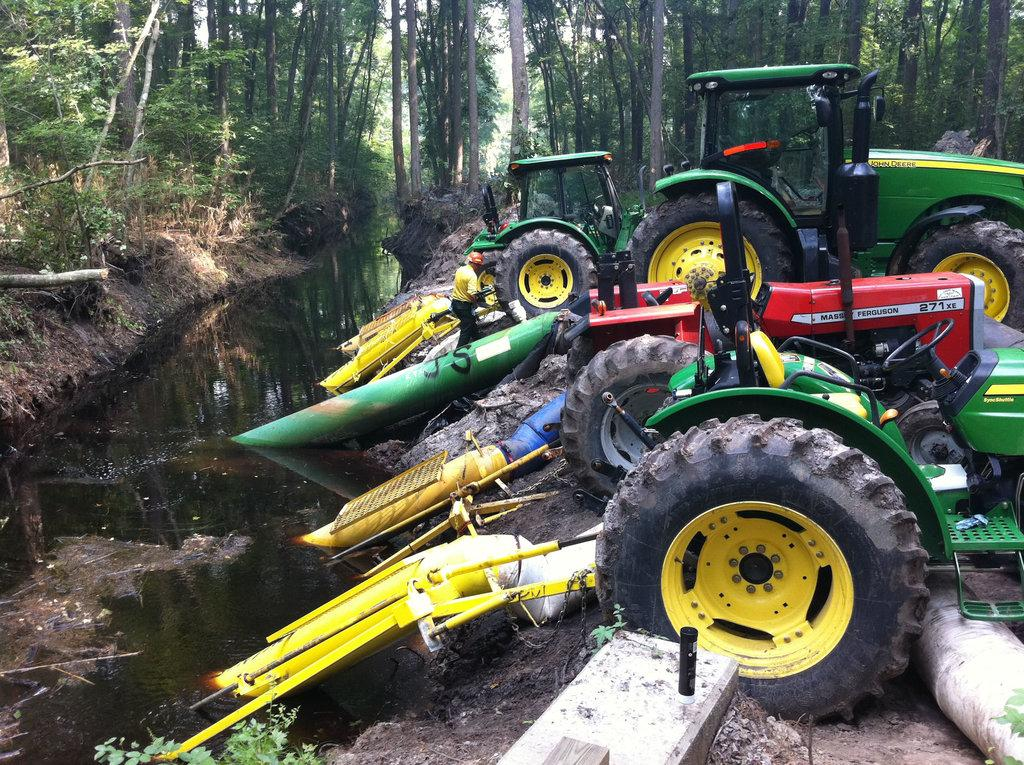What is the person in the image doing? The person is standing on the ground in the image. What else can be seen in the image besides the person? There are vehicles and trees visible in the image. What is the water visible in the image used for? The purpose of the water in the image cannot be determined from the facts provided. What is inside the box in the image? There is a bottle inside the box in the image. What type of flowers are growing near the tank in the image? There is no tank or flowers present in the image. What kind of loaf is being prepared in the image? There is no loaf or indication of food preparation in the image. 